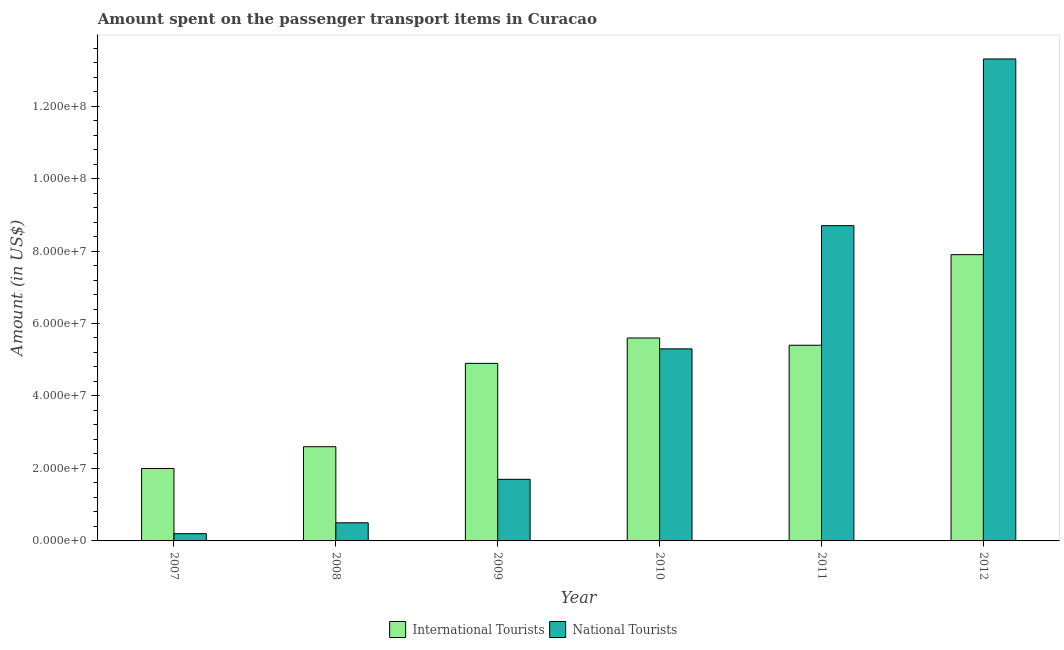Are the number of bars per tick equal to the number of legend labels?
Keep it short and to the point. Yes. Are the number of bars on each tick of the X-axis equal?
Provide a succinct answer. Yes. How many bars are there on the 4th tick from the left?
Your answer should be compact. 2. How many bars are there on the 2nd tick from the right?
Ensure brevity in your answer.  2. What is the label of the 3rd group of bars from the left?
Your answer should be compact. 2009. What is the amount spent on transport items of national tourists in 2011?
Ensure brevity in your answer.  8.70e+07. Across all years, what is the maximum amount spent on transport items of national tourists?
Ensure brevity in your answer.  1.33e+08. Across all years, what is the minimum amount spent on transport items of international tourists?
Your response must be concise. 2.00e+07. In which year was the amount spent on transport items of international tourists maximum?
Your response must be concise. 2012. What is the total amount spent on transport items of international tourists in the graph?
Give a very brief answer. 2.84e+08. What is the difference between the amount spent on transport items of international tourists in 2007 and that in 2011?
Your answer should be compact. -3.40e+07. What is the difference between the amount spent on transport items of international tourists in 2010 and the amount spent on transport items of national tourists in 2007?
Your answer should be compact. 3.60e+07. What is the average amount spent on transport items of international tourists per year?
Your response must be concise. 4.73e+07. In the year 2007, what is the difference between the amount spent on transport items of national tourists and amount spent on transport items of international tourists?
Ensure brevity in your answer.  0. In how many years, is the amount spent on transport items of national tourists greater than 68000000 US$?
Give a very brief answer. 2. What is the ratio of the amount spent on transport items of international tourists in 2009 to that in 2012?
Ensure brevity in your answer.  0.62. Is the difference between the amount spent on transport items of international tourists in 2008 and 2012 greater than the difference between the amount spent on transport items of national tourists in 2008 and 2012?
Provide a short and direct response. No. What is the difference between the highest and the second highest amount spent on transport items of national tourists?
Offer a terse response. 4.60e+07. What is the difference between the highest and the lowest amount spent on transport items of international tourists?
Your answer should be compact. 5.90e+07. In how many years, is the amount spent on transport items of national tourists greater than the average amount spent on transport items of national tourists taken over all years?
Give a very brief answer. 3. Is the sum of the amount spent on transport items of national tourists in 2010 and 2011 greater than the maximum amount spent on transport items of international tourists across all years?
Your response must be concise. Yes. What does the 2nd bar from the left in 2008 represents?
Your answer should be compact. National Tourists. What does the 1st bar from the right in 2008 represents?
Provide a succinct answer. National Tourists. Are all the bars in the graph horizontal?
Give a very brief answer. No. What is the difference between two consecutive major ticks on the Y-axis?
Offer a very short reply. 2.00e+07. Does the graph contain any zero values?
Provide a succinct answer. No. Does the graph contain grids?
Your answer should be compact. No. Where does the legend appear in the graph?
Make the answer very short. Bottom center. How are the legend labels stacked?
Provide a short and direct response. Horizontal. What is the title of the graph?
Offer a terse response. Amount spent on the passenger transport items in Curacao. What is the Amount (in US$) of International Tourists in 2007?
Keep it short and to the point. 2.00e+07. What is the Amount (in US$) of National Tourists in 2007?
Keep it short and to the point. 2.00e+06. What is the Amount (in US$) in International Tourists in 2008?
Your answer should be compact. 2.60e+07. What is the Amount (in US$) in National Tourists in 2008?
Your response must be concise. 5.00e+06. What is the Amount (in US$) in International Tourists in 2009?
Offer a very short reply. 4.90e+07. What is the Amount (in US$) in National Tourists in 2009?
Offer a terse response. 1.70e+07. What is the Amount (in US$) in International Tourists in 2010?
Your answer should be compact. 5.60e+07. What is the Amount (in US$) of National Tourists in 2010?
Ensure brevity in your answer.  5.30e+07. What is the Amount (in US$) in International Tourists in 2011?
Your response must be concise. 5.40e+07. What is the Amount (in US$) of National Tourists in 2011?
Give a very brief answer. 8.70e+07. What is the Amount (in US$) in International Tourists in 2012?
Offer a terse response. 7.90e+07. What is the Amount (in US$) in National Tourists in 2012?
Ensure brevity in your answer.  1.33e+08. Across all years, what is the maximum Amount (in US$) of International Tourists?
Provide a short and direct response. 7.90e+07. Across all years, what is the maximum Amount (in US$) of National Tourists?
Offer a very short reply. 1.33e+08. Across all years, what is the minimum Amount (in US$) in International Tourists?
Give a very brief answer. 2.00e+07. Across all years, what is the minimum Amount (in US$) in National Tourists?
Give a very brief answer. 2.00e+06. What is the total Amount (in US$) in International Tourists in the graph?
Your response must be concise. 2.84e+08. What is the total Amount (in US$) of National Tourists in the graph?
Provide a short and direct response. 2.97e+08. What is the difference between the Amount (in US$) in International Tourists in 2007 and that in 2008?
Keep it short and to the point. -6.00e+06. What is the difference between the Amount (in US$) of National Tourists in 2007 and that in 2008?
Provide a short and direct response. -3.00e+06. What is the difference between the Amount (in US$) of International Tourists in 2007 and that in 2009?
Make the answer very short. -2.90e+07. What is the difference between the Amount (in US$) in National Tourists in 2007 and that in 2009?
Offer a terse response. -1.50e+07. What is the difference between the Amount (in US$) in International Tourists in 2007 and that in 2010?
Your answer should be compact. -3.60e+07. What is the difference between the Amount (in US$) of National Tourists in 2007 and that in 2010?
Make the answer very short. -5.10e+07. What is the difference between the Amount (in US$) of International Tourists in 2007 and that in 2011?
Make the answer very short. -3.40e+07. What is the difference between the Amount (in US$) of National Tourists in 2007 and that in 2011?
Offer a terse response. -8.50e+07. What is the difference between the Amount (in US$) of International Tourists in 2007 and that in 2012?
Your answer should be compact. -5.90e+07. What is the difference between the Amount (in US$) of National Tourists in 2007 and that in 2012?
Your answer should be very brief. -1.31e+08. What is the difference between the Amount (in US$) in International Tourists in 2008 and that in 2009?
Keep it short and to the point. -2.30e+07. What is the difference between the Amount (in US$) in National Tourists in 2008 and that in 2009?
Your answer should be compact. -1.20e+07. What is the difference between the Amount (in US$) of International Tourists in 2008 and that in 2010?
Provide a short and direct response. -3.00e+07. What is the difference between the Amount (in US$) in National Tourists in 2008 and that in 2010?
Give a very brief answer. -4.80e+07. What is the difference between the Amount (in US$) in International Tourists in 2008 and that in 2011?
Give a very brief answer. -2.80e+07. What is the difference between the Amount (in US$) of National Tourists in 2008 and that in 2011?
Ensure brevity in your answer.  -8.20e+07. What is the difference between the Amount (in US$) in International Tourists in 2008 and that in 2012?
Provide a short and direct response. -5.30e+07. What is the difference between the Amount (in US$) in National Tourists in 2008 and that in 2012?
Your answer should be very brief. -1.28e+08. What is the difference between the Amount (in US$) of International Tourists in 2009 and that in 2010?
Your response must be concise. -7.00e+06. What is the difference between the Amount (in US$) of National Tourists in 2009 and that in 2010?
Make the answer very short. -3.60e+07. What is the difference between the Amount (in US$) in International Tourists in 2009 and that in 2011?
Your response must be concise. -5.00e+06. What is the difference between the Amount (in US$) of National Tourists in 2009 and that in 2011?
Offer a very short reply. -7.00e+07. What is the difference between the Amount (in US$) of International Tourists in 2009 and that in 2012?
Ensure brevity in your answer.  -3.00e+07. What is the difference between the Amount (in US$) in National Tourists in 2009 and that in 2012?
Your answer should be compact. -1.16e+08. What is the difference between the Amount (in US$) of International Tourists in 2010 and that in 2011?
Make the answer very short. 2.00e+06. What is the difference between the Amount (in US$) in National Tourists in 2010 and that in 2011?
Offer a very short reply. -3.40e+07. What is the difference between the Amount (in US$) in International Tourists in 2010 and that in 2012?
Provide a succinct answer. -2.30e+07. What is the difference between the Amount (in US$) in National Tourists in 2010 and that in 2012?
Your response must be concise. -8.00e+07. What is the difference between the Amount (in US$) of International Tourists in 2011 and that in 2012?
Your answer should be very brief. -2.50e+07. What is the difference between the Amount (in US$) of National Tourists in 2011 and that in 2012?
Your response must be concise. -4.60e+07. What is the difference between the Amount (in US$) of International Tourists in 2007 and the Amount (in US$) of National Tourists in 2008?
Your response must be concise. 1.50e+07. What is the difference between the Amount (in US$) of International Tourists in 2007 and the Amount (in US$) of National Tourists in 2010?
Give a very brief answer. -3.30e+07. What is the difference between the Amount (in US$) of International Tourists in 2007 and the Amount (in US$) of National Tourists in 2011?
Your answer should be very brief. -6.70e+07. What is the difference between the Amount (in US$) of International Tourists in 2007 and the Amount (in US$) of National Tourists in 2012?
Ensure brevity in your answer.  -1.13e+08. What is the difference between the Amount (in US$) in International Tourists in 2008 and the Amount (in US$) in National Tourists in 2009?
Your answer should be very brief. 9.00e+06. What is the difference between the Amount (in US$) of International Tourists in 2008 and the Amount (in US$) of National Tourists in 2010?
Keep it short and to the point. -2.70e+07. What is the difference between the Amount (in US$) of International Tourists in 2008 and the Amount (in US$) of National Tourists in 2011?
Make the answer very short. -6.10e+07. What is the difference between the Amount (in US$) in International Tourists in 2008 and the Amount (in US$) in National Tourists in 2012?
Your answer should be very brief. -1.07e+08. What is the difference between the Amount (in US$) of International Tourists in 2009 and the Amount (in US$) of National Tourists in 2010?
Ensure brevity in your answer.  -4.00e+06. What is the difference between the Amount (in US$) in International Tourists in 2009 and the Amount (in US$) in National Tourists in 2011?
Keep it short and to the point. -3.80e+07. What is the difference between the Amount (in US$) in International Tourists in 2009 and the Amount (in US$) in National Tourists in 2012?
Your answer should be very brief. -8.40e+07. What is the difference between the Amount (in US$) in International Tourists in 2010 and the Amount (in US$) in National Tourists in 2011?
Your answer should be compact. -3.10e+07. What is the difference between the Amount (in US$) of International Tourists in 2010 and the Amount (in US$) of National Tourists in 2012?
Your response must be concise. -7.70e+07. What is the difference between the Amount (in US$) of International Tourists in 2011 and the Amount (in US$) of National Tourists in 2012?
Your response must be concise. -7.90e+07. What is the average Amount (in US$) of International Tourists per year?
Your answer should be compact. 4.73e+07. What is the average Amount (in US$) of National Tourists per year?
Offer a very short reply. 4.95e+07. In the year 2007, what is the difference between the Amount (in US$) in International Tourists and Amount (in US$) in National Tourists?
Your answer should be very brief. 1.80e+07. In the year 2008, what is the difference between the Amount (in US$) in International Tourists and Amount (in US$) in National Tourists?
Provide a short and direct response. 2.10e+07. In the year 2009, what is the difference between the Amount (in US$) in International Tourists and Amount (in US$) in National Tourists?
Make the answer very short. 3.20e+07. In the year 2010, what is the difference between the Amount (in US$) of International Tourists and Amount (in US$) of National Tourists?
Your response must be concise. 3.00e+06. In the year 2011, what is the difference between the Amount (in US$) of International Tourists and Amount (in US$) of National Tourists?
Provide a succinct answer. -3.30e+07. In the year 2012, what is the difference between the Amount (in US$) in International Tourists and Amount (in US$) in National Tourists?
Your answer should be compact. -5.40e+07. What is the ratio of the Amount (in US$) of International Tourists in 2007 to that in 2008?
Your answer should be very brief. 0.77. What is the ratio of the Amount (in US$) of National Tourists in 2007 to that in 2008?
Ensure brevity in your answer.  0.4. What is the ratio of the Amount (in US$) of International Tourists in 2007 to that in 2009?
Keep it short and to the point. 0.41. What is the ratio of the Amount (in US$) in National Tourists in 2007 to that in 2009?
Provide a short and direct response. 0.12. What is the ratio of the Amount (in US$) of International Tourists in 2007 to that in 2010?
Your answer should be very brief. 0.36. What is the ratio of the Amount (in US$) in National Tourists in 2007 to that in 2010?
Your answer should be compact. 0.04. What is the ratio of the Amount (in US$) of International Tourists in 2007 to that in 2011?
Ensure brevity in your answer.  0.37. What is the ratio of the Amount (in US$) in National Tourists in 2007 to that in 2011?
Give a very brief answer. 0.02. What is the ratio of the Amount (in US$) of International Tourists in 2007 to that in 2012?
Your answer should be compact. 0.25. What is the ratio of the Amount (in US$) in National Tourists in 2007 to that in 2012?
Offer a very short reply. 0.01. What is the ratio of the Amount (in US$) in International Tourists in 2008 to that in 2009?
Your answer should be very brief. 0.53. What is the ratio of the Amount (in US$) in National Tourists in 2008 to that in 2009?
Your answer should be compact. 0.29. What is the ratio of the Amount (in US$) in International Tourists in 2008 to that in 2010?
Offer a very short reply. 0.46. What is the ratio of the Amount (in US$) of National Tourists in 2008 to that in 2010?
Your answer should be compact. 0.09. What is the ratio of the Amount (in US$) in International Tourists in 2008 to that in 2011?
Your answer should be very brief. 0.48. What is the ratio of the Amount (in US$) in National Tourists in 2008 to that in 2011?
Give a very brief answer. 0.06. What is the ratio of the Amount (in US$) in International Tourists in 2008 to that in 2012?
Offer a very short reply. 0.33. What is the ratio of the Amount (in US$) in National Tourists in 2008 to that in 2012?
Offer a very short reply. 0.04. What is the ratio of the Amount (in US$) of National Tourists in 2009 to that in 2010?
Ensure brevity in your answer.  0.32. What is the ratio of the Amount (in US$) of International Tourists in 2009 to that in 2011?
Make the answer very short. 0.91. What is the ratio of the Amount (in US$) of National Tourists in 2009 to that in 2011?
Offer a very short reply. 0.2. What is the ratio of the Amount (in US$) in International Tourists in 2009 to that in 2012?
Provide a succinct answer. 0.62. What is the ratio of the Amount (in US$) of National Tourists in 2009 to that in 2012?
Offer a terse response. 0.13. What is the ratio of the Amount (in US$) in National Tourists in 2010 to that in 2011?
Provide a short and direct response. 0.61. What is the ratio of the Amount (in US$) in International Tourists in 2010 to that in 2012?
Offer a very short reply. 0.71. What is the ratio of the Amount (in US$) in National Tourists in 2010 to that in 2012?
Keep it short and to the point. 0.4. What is the ratio of the Amount (in US$) in International Tourists in 2011 to that in 2012?
Your answer should be compact. 0.68. What is the ratio of the Amount (in US$) of National Tourists in 2011 to that in 2012?
Keep it short and to the point. 0.65. What is the difference between the highest and the second highest Amount (in US$) of International Tourists?
Your answer should be very brief. 2.30e+07. What is the difference between the highest and the second highest Amount (in US$) in National Tourists?
Offer a very short reply. 4.60e+07. What is the difference between the highest and the lowest Amount (in US$) of International Tourists?
Provide a succinct answer. 5.90e+07. What is the difference between the highest and the lowest Amount (in US$) in National Tourists?
Your answer should be compact. 1.31e+08. 